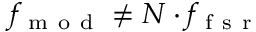<formula> <loc_0><loc_0><loc_500><loc_500>f _ { m o d } \neq N \cdot f _ { f s r }</formula> 